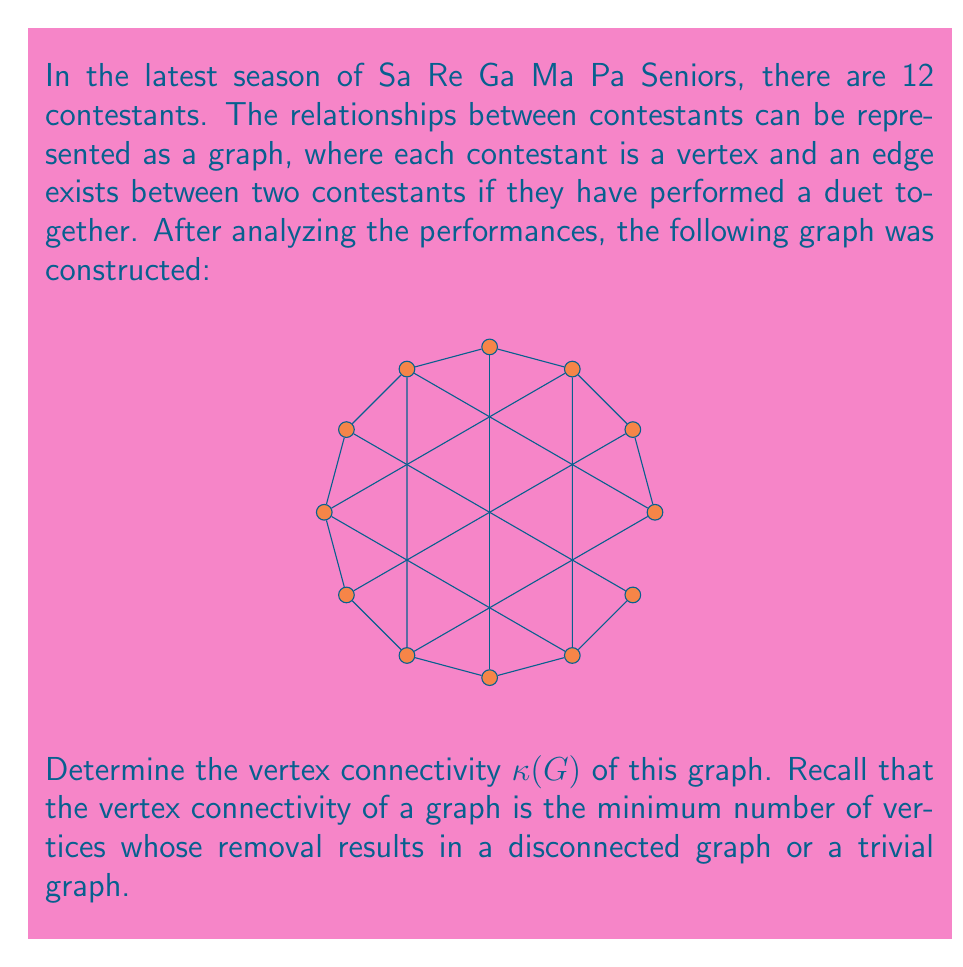Give your solution to this math problem. Let's approach this step-by-step:

1) First, we need to understand what vertex connectivity means. The vertex connectivity $\kappa(G)$ is the minimum number of vertices that need to be removed to disconnect the graph or reduce it to a single vertex.

2) Looking at the graph, we can see that it's a regular graph where each vertex has degree 4. This means it's relatively well-connected.

3) To find $\kappa(G)$, we need to find the smallest set of vertices whose removal disconnects the graph.

4) Let's start by trying to remove 1 vertex. No matter which vertex we remove, the graph remains connected. So $\kappa(G) > 1$.

5) Now, let's try removing 2 vertices. Again, no matter which 2 vertices we remove, the graph remains connected due to its structure. So $\kappa(G) > 2$.

6) Let's try removing 3 vertices. If we remove three consecutive vertices, for example, vertices representing contestants 1, 2, and 3, we can disconnect the graph.

7) To prove this is the minimum, we need to show that removing any 2 vertices will not disconnect the graph. This can be verified by trying all possible combinations of 2 vertices.

8) Therefore, the vertex connectivity of this graph is 3.

In the context of Sa Re Ga Ma Pa Seniors, this means that at least 3 contestants need to be eliminated to break the network of duet performances into disconnected groups.
Answer: $\kappa(G) = 3$ 